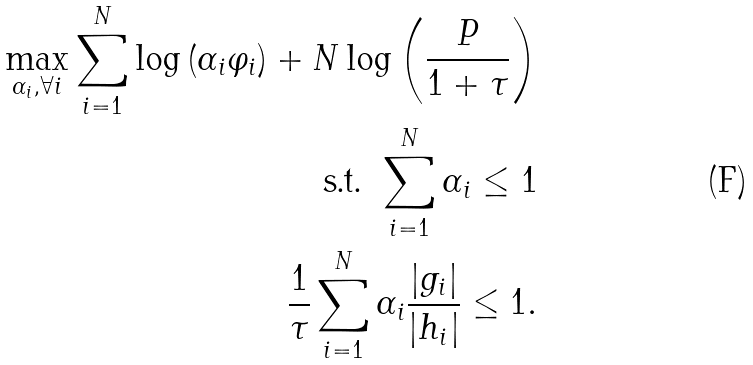<formula> <loc_0><loc_0><loc_500><loc_500>\max _ { \alpha _ { i } , \forall i } \sum _ { i = 1 } ^ { N } \log \left ( \alpha _ { i } \varphi _ { i } \right ) + N \log \left ( \frac { P } { 1 + \tau } \right ) \\ \text { s.t. } \sum _ { i = 1 } ^ { N } \alpha _ { i } \leq 1 \\ \frac { 1 } { \tau } \sum _ { i = 1 } ^ { N } \alpha _ { i } \frac { | g _ { i } | } { | h _ { i } | } \leq 1 .</formula> 